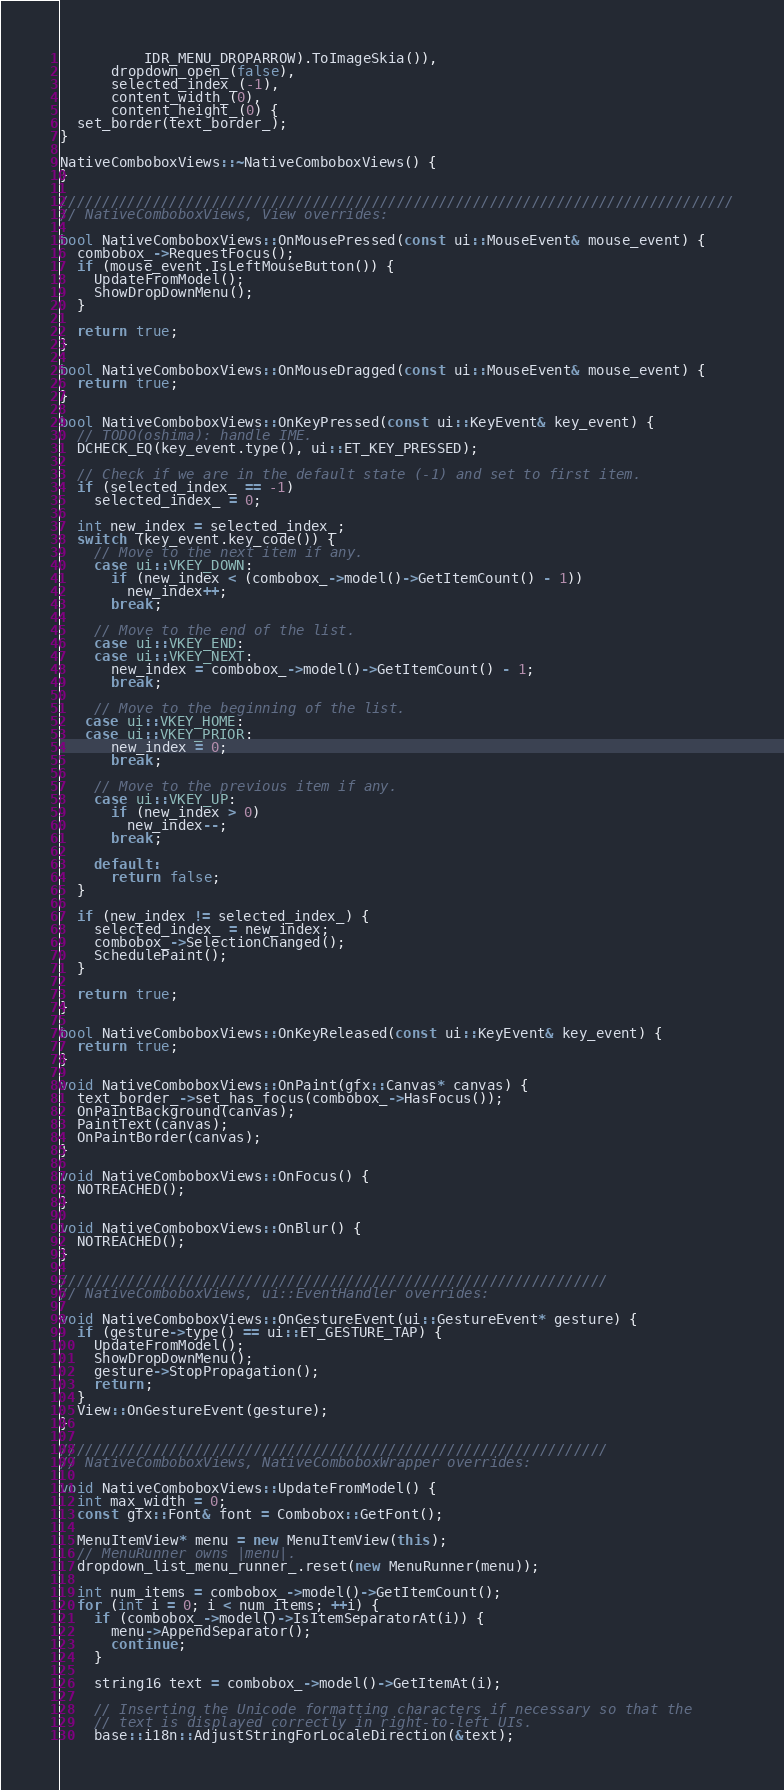Convert code to text. <code><loc_0><loc_0><loc_500><loc_500><_C++_>          IDR_MENU_DROPARROW).ToImageSkia()),
      dropdown_open_(false),
      selected_index_(-1),
      content_width_(0),
      content_height_(0) {
  set_border(text_border_);
}

NativeComboboxViews::~NativeComboboxViews() {
}

////////////////////////////////////////////////////////////////////////////////
// NativeComboboxViews, View overrides:

bool NativeComboboxViews::OnMousePressed(const ui::MouseEvent& mouse_event) {
  combobox_->RequestFocus();
  if (mouse_event.IsLeftMouseButton()) {
    UpdateFromModel();
    ShowDropDownMenu();
  }

  return true;
}

bool NativeComboboxViews::OnMouseDragged(const ui::MouseEvent& mouse_event) {
  return true;
}

bool NativeComboboxViews::OnKeyPressed(const ui::KeyEvent& key_event) {
  // TODO(oshima): handle IME.
  DCHECK_EQ(key_event.type(), ui::ET_KEY_PRESSED);

  // Check if we are in the default state (-1) and set to first item.
  if (selected_index_ == -1)
    selected_index_ = 0;

  int new_index = selected_index_;
  switch (key_event.key_code()) {
    // Move to the next item if any.
    case ui::VKEY_DOWN:
      if (new_index < (combobox_->model()->GetItemCount() - 1))
        new_index++;
      break;

    // Move to the end of the list.
    case ui::VKEY_END:
    case ui::VKEY_NEXT:
      new_index = combobox_->model()->GetItemCount() - 1;
      break;

    // Move to the beginning of the list.
   case ui::VKEY_HOME:
   case ui::VKEY_PRIOR:
      new_index = 0;
      break;

    // Move to the previous item if any.
    case ui::VKEY_UP:
      if (new_index > 0)
        new_index--;
      break;

    default:
      return false;
  }

  if (new_index != selected_index_) {
    selected_index_ = new_index;
    combobox_->SelectionChanged();
    SchedulePaint();
  }

  return true;
}

bool NativeComboboxViews::OnKeyReleased(const ui::KeyEvent& key_event) {
  return true;
}

void NativeComboboxViews::OnPaint(gfx::Canvas* canvas) {
  text_border_->set_has_focus(combobox_->HasFocus());
  OnPaintBackground(canvas);
  PaintText(canvas);
  OnPaintBorder(canvas);
}

void NativeComboboxViews::OnFocus() {
  NOTREACHED();
}

void NativeComboboxViews::OnBlur() {
  NOTREACHED();
}

/////////////////////////////////////////////////////////////////
// NativeComboboxViews, ui::EventHandler overrides:

void NativeComboboxViews::OnGestureEvent(ui::GestureEvent* gesture) {
  if (gesture->type() == ui::ET_GESTURE_TAP) {
    UpdateFromModel();
    ShowDropDownMenu();
    gesture->StopPropagation();
    return;
  }
  View::OnGestureEvent(gesture);
}

/////////////////////////////////////////////////////////////////
// NativeComboboxViews, NativeComboboxWrapper overrides:

void NativeComboboxViews::UpdateFromModel() {
  int max_width = 0;
  const gfx::Font& font = Combobox::GetFont();

  MenuItemView* menu = new MenuItemView(this);
  // MenuRunner owns |menu|.
  dropdown_list_menu_runner_.reset(new MenuRunner(menu));

  int num_items = combobox_->model()->GetItemCount();
  for (int i = 0; i < num_items; ++i) {
    if (combobox_->model()->IsItemSeparatorAt(i)) {
      menu->AppendSeparator();
      continue;
    }

    string16 text = combobox_->model()->GetItemAt(i);

    // Inserting the Unicode formatting characters if necessary so that the
    // text is displayed correctly in right-to-left UIs.
    base::i18n::AdjustStringForLocaleDirection(&text);
</code> 